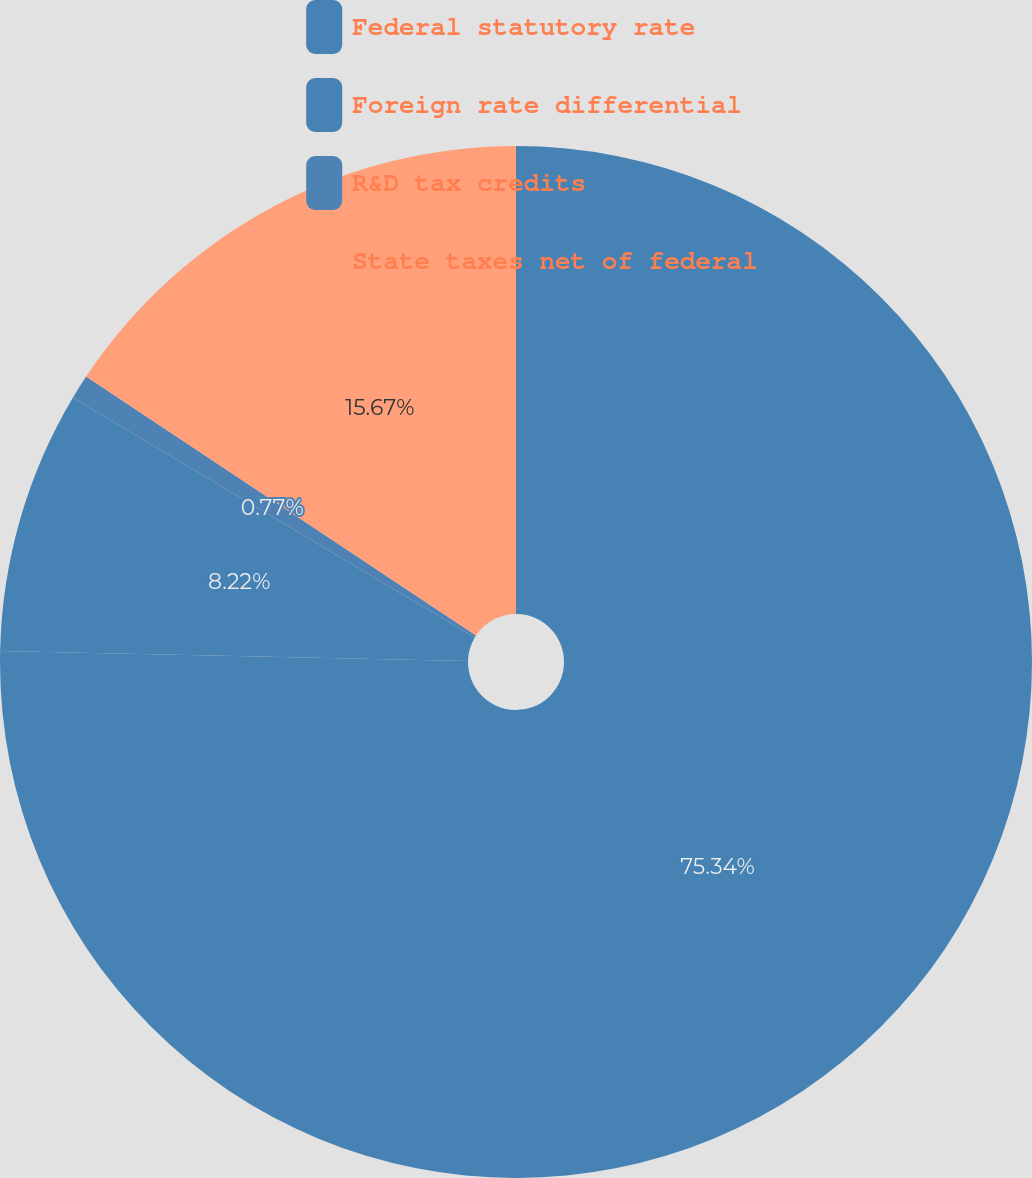Convert chart to OTSL. <chart><loc_0><loc_0><loc_500><loc_500><pie_chart><fcel>Federal statutory rate<fcel>Foreign rate differential<fcel>R&D tax credits<fcel>State taxes net of federal<nl><fcel>75.33%<fcel>8.22%<fcel>0.77%<fcel>15.67%<nl></chart> 